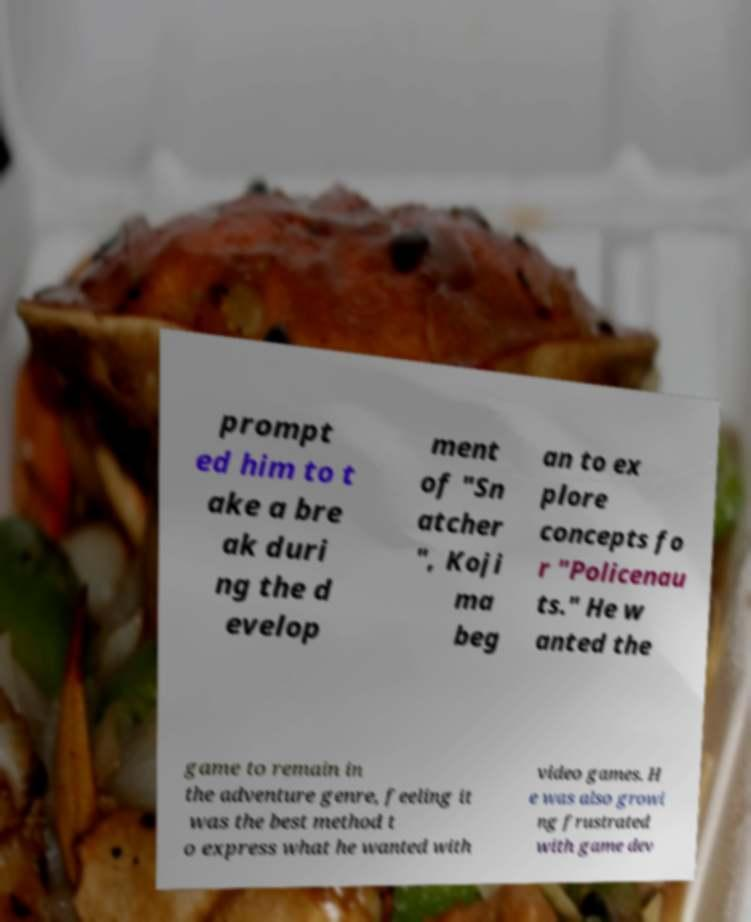Can you accurately transcribe the text from the provided image for me? prompt ed him to t ake a bre ak duri ng the d evelop ment of "Sn atcher ", Koji ma beg an to ex plore concepts fo r "Policenau ts." He w anted the game to remain in the adventure genre, feeling it was the best method t o express what he wanted with video games. H e was also growi ng frustrated with game dev 